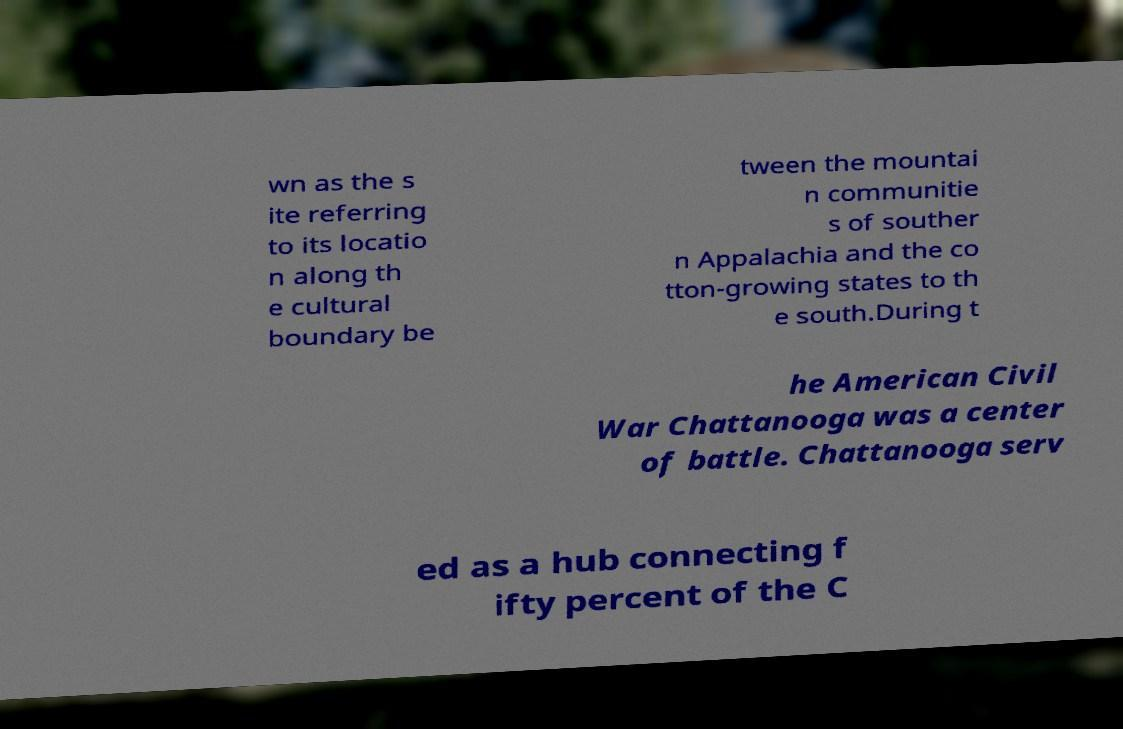I need the written content from this picture converted into text. Can you do that? wn as the s ite referring to its locatio n along th e cultural boundary be tween the mountai n communitie s of souther n Appalachia and the co tton-growing states to th e south.During t he American Civil War Chattanooga was a center of battle. Chattanooga serv ed as a hub connecting f ifty percent of the C 